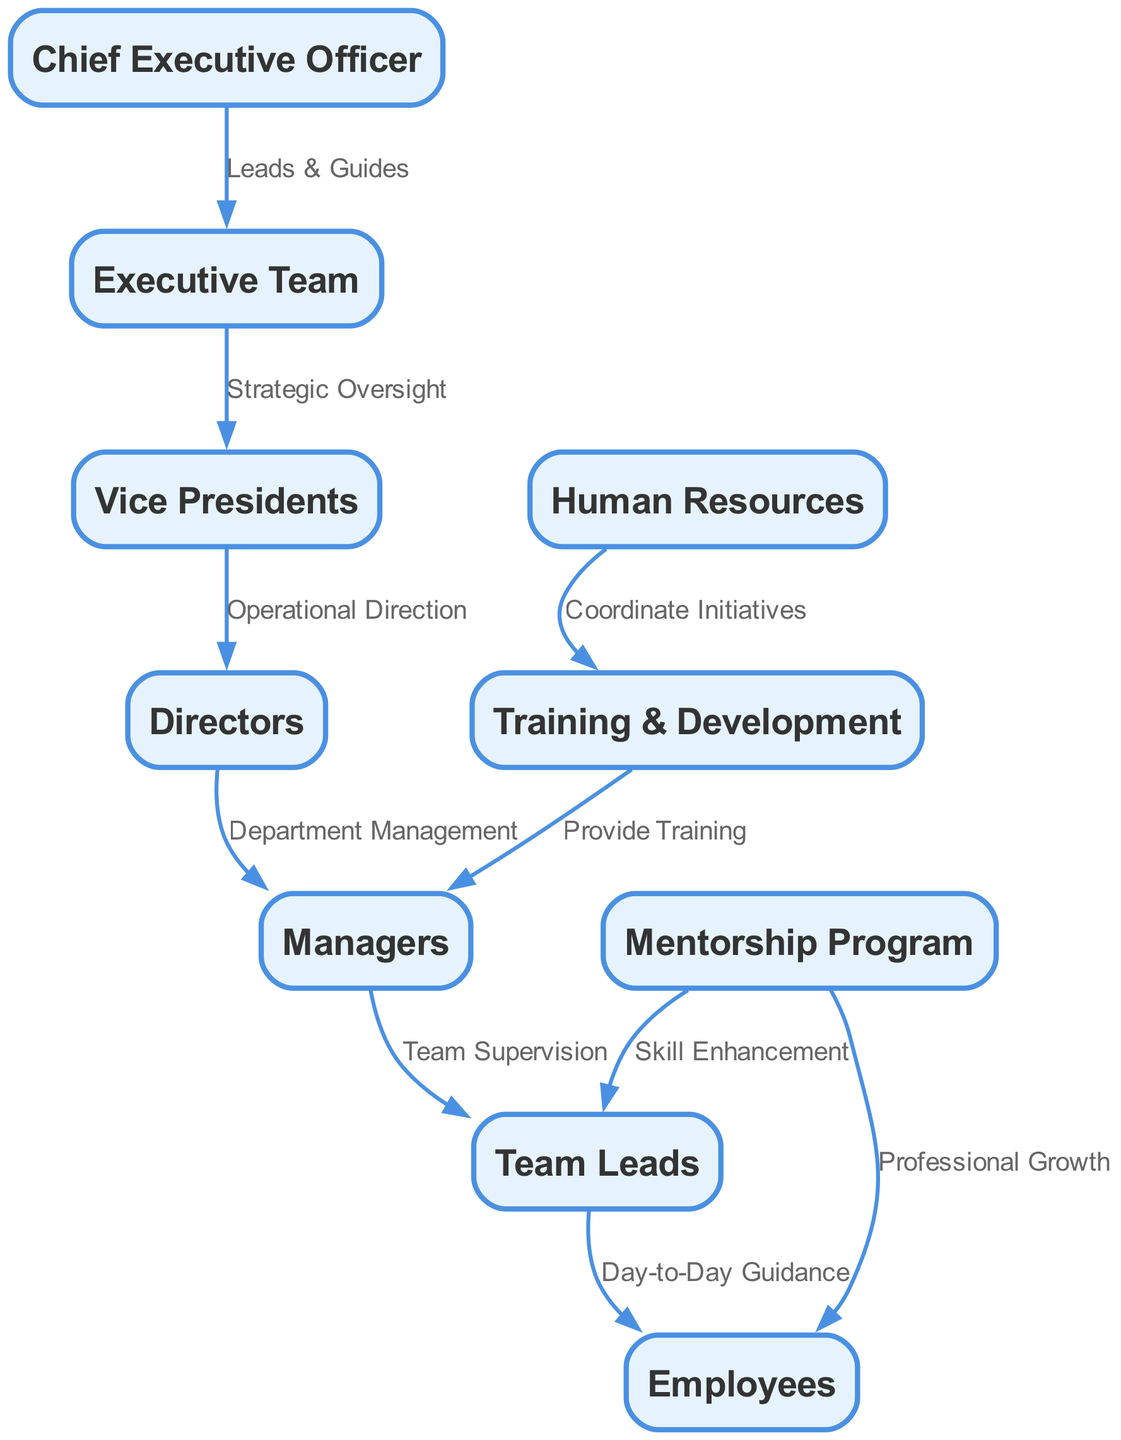What is the highest position in this organizational chain? The highest position is represented by the node "CEO." This is confirmed by recognizing that there are no nodes above the CEO in the diagram, indicating that it is the top of the hierarchy.
Answer: Chief Executive Officer How many nodes are present in the diagram? The number of nodes can be counted directly from the list provided in the "nodes" section. There are 10 distinct nodes defined, which include positions and departments relevant to mentorship and professional development.
Answer: 10 Which department coordinates training initiatives? The department that coordinates initiatives is depicted by the "HRDept" node, which has an edge leading to "TrainingDept" indicating its role in overseeing training coordination.
Answer: Human Resources Who provides training to managers? The "TrainingDept" provides training to managers as indicated by the edge that directs from the "TrainingDept" to "Managers," showcasing the flow of responsibility for training.
Answer: Training & Development What is the relationship between Executive Team and Vice Presidents? The relationship is defined as "Strategic Oversight," shown by the direct edge connecting "ExecTeam" to "VP," outlining the Executive Team's role in overseeing vice presidents.
Answer: Strategic Oversight Which node has a direct link to Employees for professional growth? The "MentorshipProgram" node links directly to "Employees," indicating it plays a role in their professional development as described in the edge labeled "Professional Growth."
Answer: Mentorship Program How many edges are listed that connect managers to other nodes? By analyzing the edges, there are four direct relationships emerging from "Managers" to other positions, including "Leads," "TrainingDept," and implicitly to "Employees" through "MentorshipProgram."
Answer: 3 What is the role of Team Leads in this structure? The "Leads" node is linked to "Employees," indicating that Team Leads provide "Day-to-Day Guidance" to the Employees, defining their position as essential for daily interactions and support.
Answer: Day-to-Day Guidance Which node enhances skills specifically for Team Leads? The node that enhances skills for Team Leads is the "MentorshipProgram." This is illustrated by the direct connection establishing "Skill Enhancement" for Team Leads.
Answer: Mentorship Program 